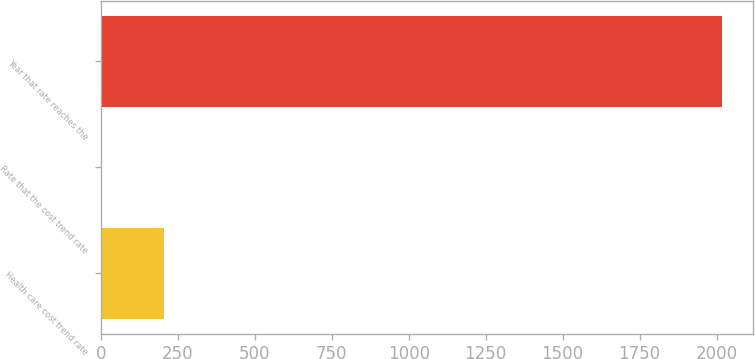Convert chart. <chart><loc_0><loc_0><loc_500><loc_500><bar_chart><fcel>Health care cost trend rate<fcel>Rate that the cost trend rate<fcel>Year that rate reaches the<nl><fcel>206.4<fcel>5<fcel>2019<nl></chart> 